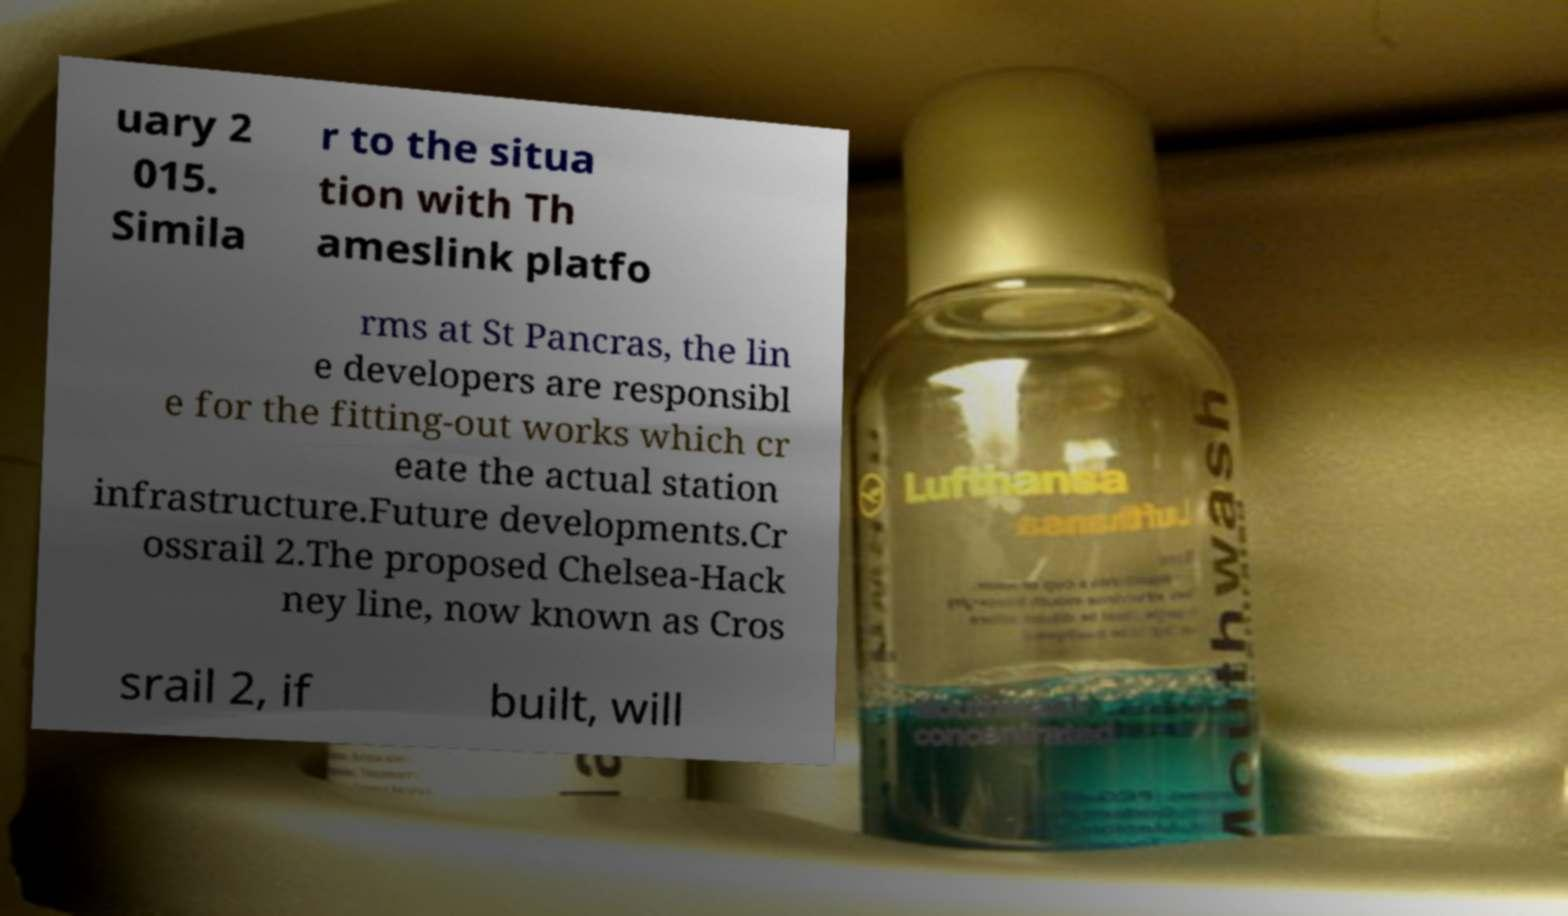Please read and relay the text visible in this image. What does it say? uary 2 015. Simila r to the situa tion with Th ameslink platfo rms at St Pancras, the lin e developers are responsibl e for the fitting-out works which cr eate the actual station infrastructure.Future developments.Cr ossrail 2.The proposed Chelsea-Hack ney line, now known as Cros srail 2, if built, will 